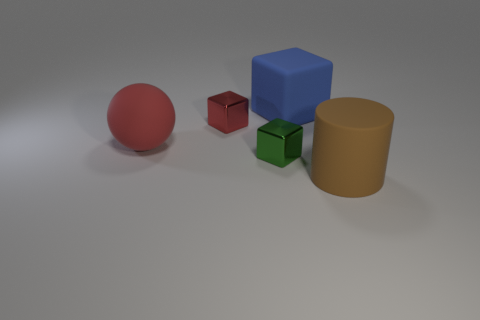Are the big red thing and the small thing that is behind the tiny green thing made of the same material?
Keep it short and to the point. No. There is a big matte object that is behind the small object behind the red matte object; what is its shape?
Make the answer very short. Cube. What number of tiny objects are metallic blocks or cyan blocks?
Offer a very short reply. 2. What number of small green metal things are the same shape as the blue object?
Your response must be concise. 1. There is a blue matte object; does it have the same shape as the rubber thing that is left of the small green block?
Provide a succinct answer. No. How many brown cylinders are in front of the cylinder?
Offer a very short reply. 0. Are there any other rubber balls that have the same size as the sphere?
Offer a terse response. No. Does the metallic thing that is in front of the small red metal object have the same shape as the large brown matte object?
Your response must be concise. No. What color is the big rubber block?
Your answer should be compact. Blue. What shape is the tiny shiny thing that is the same color as the big sphere?
Your answer should be very brief. Cube. 